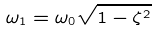Convert formula to latex. <formula><loc_0><loc_0><loc_500><loc_500>\omega _ { 1 } = \omega _ { 0 } \sqrt { 1 - \zeta ^ { 2 } }</formula> 